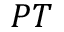<formula> <loc_0><loc_0><loc_500><loc_500>P T</formula> 